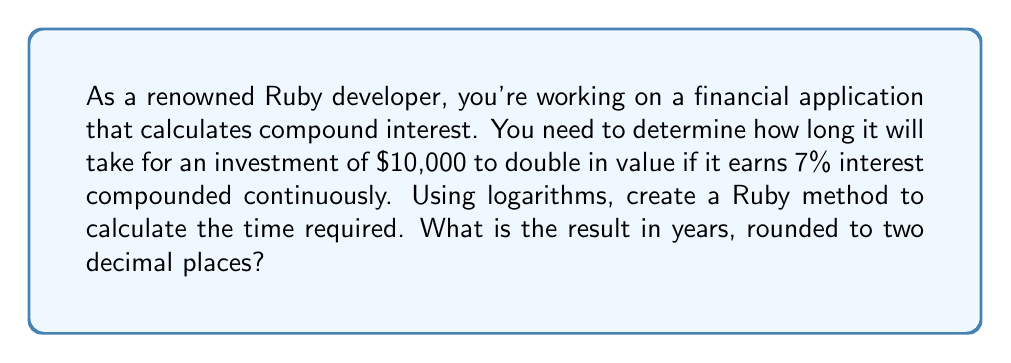Show me your answer to this math problem. To solve this problem, we'll use the continuous compound interest formula and logarithms. Let's break it down step by step:

1. The continuous compound interest formula is:
   $$A = P \cdot e^{rt}$$
   Where:
   $A$ is the final amount
   $P$ is the principal (initial investment)
   $e$ is Euler's number (approximately 2.71828)
   $r$ is the interest rate (as a decimal)
   $t$ is the time in years

2. We want to find when the amount doubles, so:
   $$2P = P \cdot e^{rt}$$

3. Simplify by dividing both sides by $P$:
   $$2 = e^{rt}$$

4. Take the natural logarithm of both sides:
   $$\ln(2) = \ln(e^{rt})$$

5. Simplify the right side using logarithm properties:
   $$\ln(2) = rt$$

6. Solve for $t$:
   $$t = \frac{\ln(2)}{r}$$

7. Now, let's implement this in Ruby:

   ```ruby
   def time_to_double(rate)
     (Math.log(2) / rate).round(2)
   end

   result = time_to_double(0.07)
   puts result
   ```

8. Calculate:
   $$t = \frac{\ln(2)}{0.07} \approx 9.9$$

The Ruby method will return this value rounded to two decimal places.
Answer: 9.90 years 